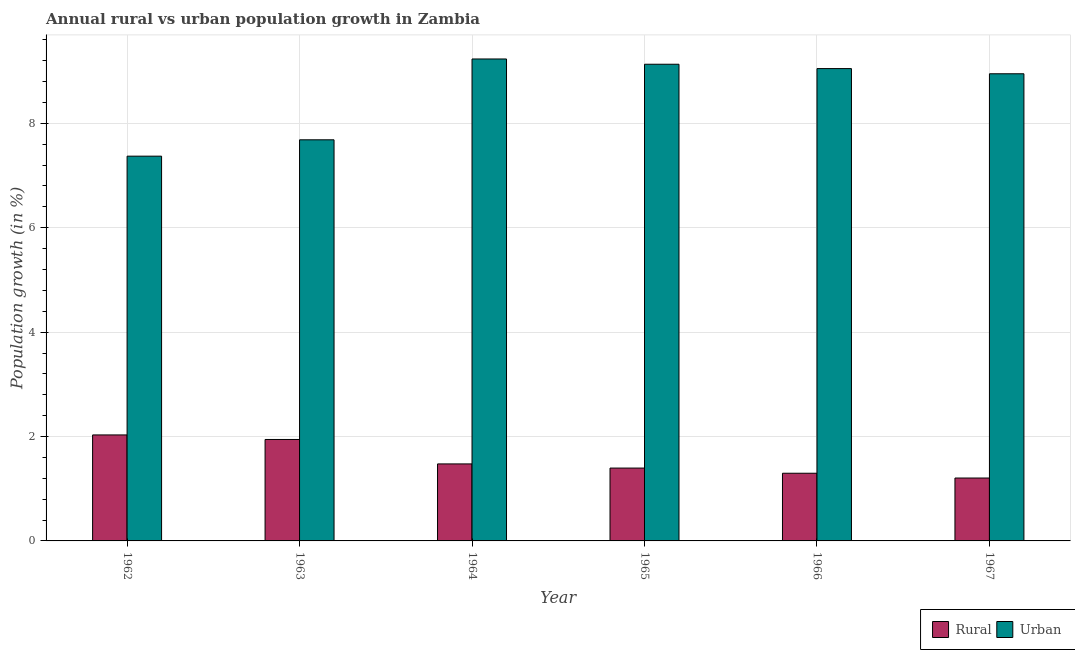How many different coloured bars are there?
Your response must be concise. 2. Are the number of bars on each tick of the X-axis equal?
Make the answer very short. Yes. How many bars are there on the 5th tick from the left?
Provide a short and direct response. 2. What is the label of the 5th group of bars from the left?
Offer a terse response. 1966. What is the urban population growth in 1967?
Give a very brief answer. 8.95. Across all years, what is the maximum urban population growth?
Your answer should be very brief. 9.23. Across all years, what is the minimum urban population growth?
Provide a succinct answer. 7.37. In which year was the urban population growth maximum?
Offer a terse response. 1964. In which year was the rural population growth minimum?
Your answer should be very brief. 1967. What is the total urban population growth in the graph?
Make the answer very short. 51.42. What is the difference between the rural population growth in 1966 and that in 1967?
Provide a short and direct response. 0.09. What is the difference between the urban population growth in 1964 and the rural population growth in 1962?
Offer a very short reply. 1.86. What is the average rural population growth per year?
Your answer should be very brief. 1.56. In how many years, is the urban population growth greater than 5.2 %?
Offer a very short reply. 6. What is the ratio of the urban population growth in 1963 to that in 1965?
Your answer should be very brief. 0.84. Is the urban population growth in 1963 less than that in 1966?
Your answer should be compact. Yes. What is the difference between the highest and the second highest rural population growth?
Keep it short and to the point. 0.09. What is the difference between the highest and the lowest urban population growth?
Your response must be concise. 1.86. What does the 2nd bar from the left in 1964 represents?
Keep it short and to the point. Urban . What does the 1st bar from the right in 1965 represents?
Your answer should be very brief. Urban . Are all the bars in the graph horizontal?
Provide a short and direct response. No. Are the values on the major ticks of Y-axis written in scientific E-notation?
Ensure brevity in your answer.  No. Does the graph contain any zero values?
Your response must be concise. No. How are the legend labels stacked?
Make the answer very short. Horizontal. What is the title of the graph?
Ensure brevity in your answer.  Annual rural vs urban population growth in Zambia. Does "Taxes on exports" appear as one of the legend labels in the graph?
Make the answer very short. No. What is the label or title of the Y-axis?
Offer a very short reply. Population growth (in %). What is the Population growth (in %) in Rural in 1962?
Ensure brevity in your answer.  2.03. What is the Population growth (in %) of Urban  in 1962?
Provide a succinct answer. 7.37. What is the Population growth (in %) of Rural in 1963?
Your answer should be very brief. 1.94. What is the Population growth (in %) of Urban  in 1963?
Your answer should be compact. 7.68. What is the Population growth (in %) in Rural in 1964?
Keep it short and to the point. 1.48. What is the Population growth (in %) of Urban  in 1964?
Provide a succinct answer. 9.23. What is the Population growth (in %) of Rural in 1965?
Your answer should be very brief. 1.4. What is the Population growth (in %) in Urban  in 1965?
Give a very brief answer. 9.13. What is the Population growth (in %) in Rural in 1966?
Provide a succinct answer. 1.3. What is the Population growth (in %) of Urban  in 1966?
Offer a terse response. 9.05. What is the Population growth (in %) of Rural in 1967?
Your response must be concise. 1.21. What is the Population growth (in %) in Urban  in 1967?
Your response must be concise. 8.95. Across all years, what is the maximum Population growth (in %) of Rural?
Your answer should be very brief. 2.03. Across all years, what is the maximum Population growth (in %) of Urban ?
Your response must be concise. 9.23. Across all years, what is the minimum Population growth (in %) of Rural?
Your answer should be compact. 1.21. Across all years, what is the minimum Population growth (in %) in Urban ?
Your answer should be compact. 7.37. What is the total Population growth (in %) of Rural in the graph?
Your answer should be compact. 9.35. What is the total Population growth (in %) in Urban  in the graph?
Your answer should be very brief. 51.42. What is the difference between the Population growth (in %) in Rural in 1962 and that in 1963?
Your answer should be compact. 0.09. What is the difference between the Population growth (in %) of Urban  in 1962 and that in 1963?
Offer a terse response. -0.31. What is the difference between the Population growth (in %) in Rural in 1962 and that in 1964?
Make the answer very short. 0.56. What is the difference between the Population growth (in %) of Urban  in 1962 and that in 1964?
Provide a succinct answer. -1.86. What is the difference between the Population growth (in %) in Rural in 1962 and that in 1965?
Your answer should be very brief. 0.63. What is the difference between the Population growth (in %) in Urban  in 1962 and that in 1965?
Ensure brevity in your answer.  -1.76. What is the difference between the Population growth (in %) of Rural in 1962 and that in 1966?
Keep it short and to the point. 0.73. What is the difference between the Population growth (in %) of Urban  in 1962 and that in 1966?
Provide a succinct answer. -1.68. What is the difference between the Population growth (in %) in Rural in 1962 and that in 1967?
Your answer should be very brief. 0.83. What is the difference between the Population growth (in %) of Urban  in 1962 and that in 1967?
Keep it short and to the point. -1.58. What is the difference between the Population growth (in %) of Rural in 1963 and that in 1964?
Your response must be concise. 0.47. What is the difference between the Population growth (in %) of Urban  in 1963 and that in 1964?
Make the answer very short. -1.55. What is the difference between the Population growth (in %) in Rural in 1963 and that in 1965?
Offer a very short reply. 0.55. What is the difference between the Population growth (in %) in Urban  in 1963 and that in 1965?
Make the answer very short. -1.45. What is the difference between the Population growth (in %) in Rural in 1963 and that in 1966?
Provide a succinct answer. 0.65. What is the difference between the Population growth (in %) in Urban  in 1963 and that in 1966?
Keep it short and to the point. -1.36. What is the difference between the Population growth (in %) in Rural in 1963 and that in 1967?
Make the answer very short. 0.74. What is the difference between the Population growth (in %) of Urban  in 1963 and that in 1967?
Provide a short and direct response. -1.27. What is the difference between the Population growth (in %) in Rural in 1964 and that in 1965?
Your answer should be very brief. 0.08. What is the difference between the Population growth (in %) of Urban  in 1964 and that in 1965?
Ensure brevity in your answer.  0.1. What is the difference between the Population growth (in %) of Rural in 1964 and that in 1966?
Your answer should be compact. 0.18. What is the difference between the Population growth (in %) of Urban  in 1964 and that in 1966?
Make the answer very short. 0.18. What is the difference between the Population growth (in %) in Rural in 1964 and that in 1967?
Give a very brief answer. 0.27. What is the difference between the Population growth (in %) in Urban  in 1964 and that in 1967?
Offer a terse response. 0.28. What is the difference between the Population growth (in %) of Rural in 1965 and that in 1966?
Make the answer very short. 0.1. What is the difference between the Population growth (in %) of Urban  in 1965 and that in 1966?
Make the answer very short. 0.08. What is the difference between the Population growth (in %) of Rural in 1965 and that in 1967?
Keep it short and to the point. 0.19. What is the difference between the Population growth (in %) in Urban  in 1965 and that in 1967?
Give a very brief answer. 0.18. What is the difference between the Population growth (in %) of Rural in 1966 and that in 1967?
Your answer should be very brief. 0.09. What is the difference between the Population growth (in %) in Urban  in 1966 and that in 1967?
Give a very brief answer. 0.1. What is the difference between the Population growth (in %) in Rural in 1962 and the Population growth (in %) in Urban  in 1963?
Offer a terse response. -5.65. What is the difference between the Population growth (in %) of Rural in 1962 and the Population growth (in %) of Urban  in 1964?
Keep it short and to the point. -7.2. What is the difference between the Population growth (in %) in Rural in 1962 and the Population growth (in %) in Urban  in 1965?
Provide a succinct answer. -7.1. What is the difference between the Population growth (in %) of Rural in 1962 and the Population growth (in %) of Urban  in 1966?
Make the answer very short. -7.02. What is the difference between the Population growth (in %) of Rural in 1962 and the Population growth (in %) of Urban  in 1967?
Ensure brevity in your answer.  -6.92. What is the difference between the Population growth (in %) of Rural in 1963 and the Population growth (in %) of Urban  in 1964?
Your answer should be very brief. -7.29. What is the difference between the Population growth (in %) in Rural in 1963 and the Population growth (in %) in Urban  in 1965?
Ensure brevity in your answer.  -7.19. What is the difference between the Population growth (in %) of Rural in 1963 and the Population growth (in %) of Urban  in 1966?
Give a very brief answer. -7.11. What is the difference between the Population growth (in %) of Rural in 1963 and the Population growth (in %) of Urban  in 1967?
Offer a very short reply. -7.01. What is the difference between the Population growth (in %) of Rural in 1964 and the Population growth (in %) of Urban  in 1965?
Provide a succinct answer. -7.66. What is the difference between the Population growth (in %) of Rural in 1964 and the Population growth (in %) of Urban  in 1966?
Give a very brief answer. -7.57. What is the difference between the Population growth (in %) in Rural in 1964 and the Population growth (in %) in Urban  in 1967?
Your answer should be compact. -7.47. What is the difference between the Population growth (in %) in Rural in 1965 and the Population growth (in %) in Urban  in 1966?
Make the answer very short. -7.65. What is the difference between the Population growth (in %) in Rural in 1965 and the Population growth (in %) in Urban  in 1967?
Offer a terse response. -7.55. What is the difference between the Population growth (in %) in Rural in 1966 and the Population growth (in %) in Urban  in 1967?
Provide a succinct answer. -7.65. What is the average Population growth (in %) of Rural per year?
Ensure brevity in your answer.  1.56. What is the average Population growth (in %) of Urban  per year?
Offer a terse response. 8.57. In the year 1962, what is the difference between the Population growth (in %) of Rural and Population growth (in %) of Urban ?
Offer a very short reply. -5.34. In the year 1963, what is the difference between the Population growth (in %) in Rural and Population growth (in %) in Urban ?
Give a very brief answer. -5.74. In the year 1964, what is the difference between the Population growth (in %) in Rural and Population growth (in %) in Urban ?
Ensure brevity in your answer.  -7.76. In the year 1965, what is the difference between the Population growth (in %) of Rural and Population growth (in %) of Urban ?
Give a very brief answer. -7.74. In the year 1966, what is the difference between the Population growth (in %) of Rural and Population growth (in %) of Urban ?
Offer a very short reply. -7.75. In the year 1967, what is the difference between the Population growth (in %) in Rural and Population growth (in %) in Urban ?
Ensure brevity in your answer.  -7.75. What is the ratio of the Population growth (in %) in Rural in 1962 to that in 1963?
Your response must be concise. 1.04. What is the ratio of the Population growth (in %) in Urban  in 1962 to that in 1963?
Offer a terse response. 0.96. What is the ratio of the Population growth (in %) of Rural in 1962 to that in 1964?
Provide a succinct answer. 1.38. What is the ratio of the Population growth (in %) in Urban  in 1962 to that in 1964?
Your response must be concise. 0.8. What is the ratio of the Population growth (in %) of Rural in 1962 to that in 1965?
Ensure brevity in your answer.  1.45. What is the ratio of the Population growth (in %) of Urban  in 1962 to that in 1965?
Provide a short and direct response. 0.81. What is the ratio of the Population growth (in %) in Rural in 1962 to that in 1966?
Keep it short and to the point. 1.57. What is the ratio of the Population growth (in %) in Urban  in 1962 to that in 1966?
Make the answer very short. 0.81. What is the ratio of the Population growth (in %) of Rural in 1962 to that in 1967?
Ensure brevity in your answer.  1.69. What is the ratio of the Population growth (in %) of Urban  in 1962 to that in 1967?
Your answer should be compact. 0.82. What is the ratio of the Population growth (in %) of Rural in 1963 to that in 1964?
Give a very brief answer. 1.32. What is the ratio of the Population growth (in %) of Urban  in 1963 to that in 1964?
Give a very brief answer. 0.83. What is the ratio of the Population growth (in %) of Rural in 1963 to that in 1965?
Keep it short and to the point. 1.39. What is the ratio of the Population growth (in %) in Urban  in 1963 to that in 1965?
Offer a terse response. 0.84. What is the ratio of the Population growth (in %) of Rural in 1963 to that in 1966?
Your answer should be very brief. 1.5. What is the ratio of the Population growth (in %) of Urban  in 1963 to that in 1966?
Make the answer very short. 0.85. What is the ratio of the Population growth (in %) in Rural in 1963 to that in 1967?
Your answer should be very brief. 1.61. What is the ratio of the Population growth (in %) in Urban  in 1963 to that in 1967?
Give a very brief answer. 0.86. What is the ratio of the Population growth (in %) of Rural in 1964 to that in 1965?
Your answer should be very brief. 1.06. What is the ratio of the Population growth (in %) of Urban  in 1964 to that in 1965?
Offer a very short reply. 1.01. What is the ratio of the Population growth (in %) of Rural in 1964 to that in 1966?
Provide a short and direct response. 1.14. What is the ratio of the Population growth (in %) of Urban  in 1964 to that in 1966?
Make the answer very short. 1.02. What is the ratio of the Population growth (in %) in Rural in 1964 to that in 1967?
Your answer should be compact. 1.22. What is the ratio of the Population growth (in %) of Urban  in 1964 to that in 1967?
Offer a very short reply. 1.03. What is the ratio of the Population growth (in %) in Rural in 1965 to that in 1966?
Provide a short and direct response. 1.08. What is the ratio of the Population growth (in %) in Urban  in 1965 to that in 1966?
Ensure brevity in your answer.  1.01. What is the ratio of the Population growth (in %) of Rural in 1965 to that in 1967?
Your response must be concise. 1.16. What is the ratio of the Population growth (in %) in Urban  in 1965 to that in 1967?
Keep it short and to the point. 1.02. What is the ratio of the Population growth (in %) of Rural in 1966 to that in 1967?
Your answer should be compact. 1.08. What is the ratio of the Population growth (in %) in Urban  in 1966 to that in 1967?
Keep it short and to the point. 1.01. What is the difference between the highest and the second highest Population growth (in %) in Rural?
Give a very brief answer. 0.09. What is the difference between the highest and the second highest Population growth (in %) of Urban ?
Make the answer very short. 0.1. What is the difference between the highest and the lowest Population growth (in %) in Rural?
Provide a succinct answer. 0.83. What is the difference between the highest and the lowest Population growth (in %) of Urban ?
Ensure brevity in your answer.  1.86. 